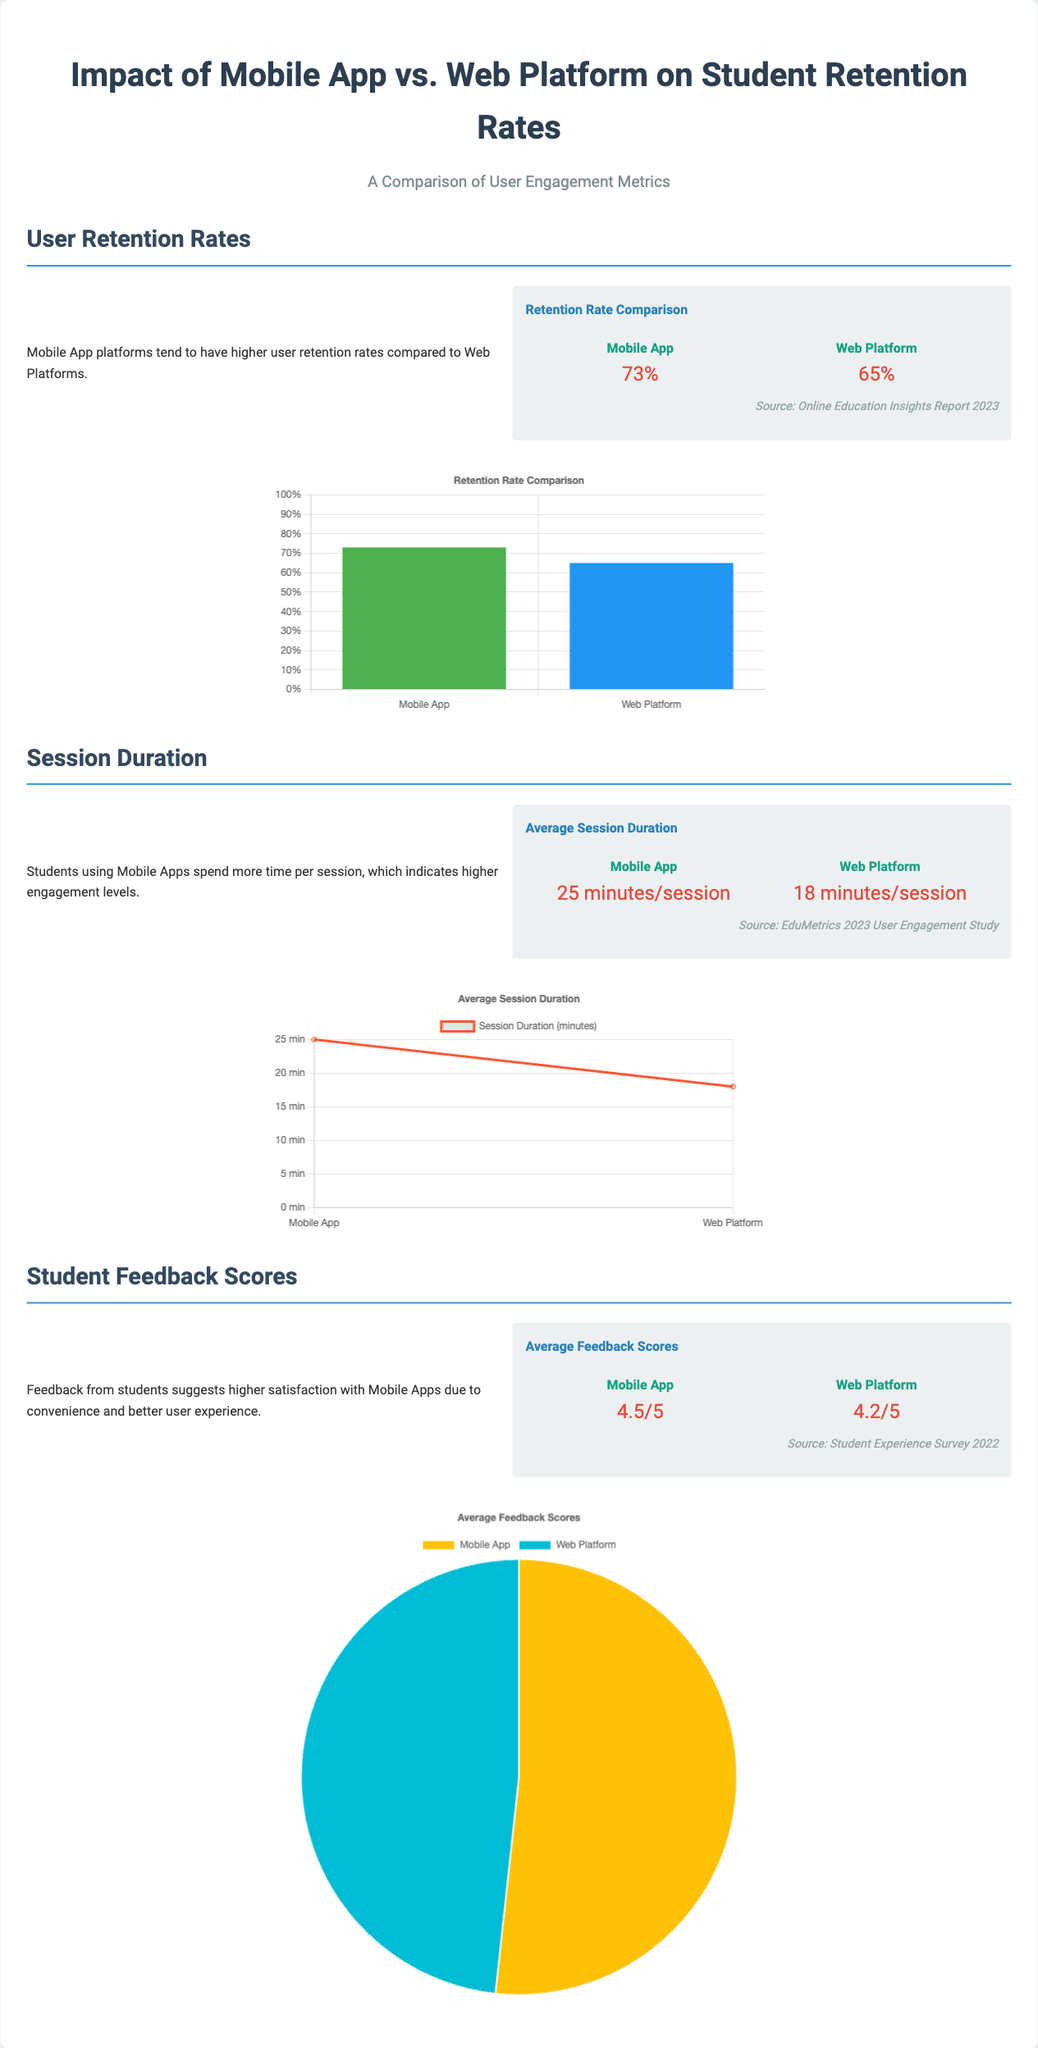what is the retention rate for Mobile App users? The document provides a specific statistic, stating that the retention rate for Mobile App users is 73%.
Answer: 73% what is the average session duration for Web Platform users? According to the document, the average session duration for Web Platform users is mentioned as 18 minutes/session.
Answer: 18 minutes/session which platform has a higher average feedback score? The document compares feedback scores and shows that the Mobile App has a higher average score of 4.5/5 compared to the Web Platform.
Answer: Mobile App what is the average feedback score for Mobile App users? The document states that the average feedback score for Mobile App users is 4.5 out of 5.
Answer: 4.5/5 which user engagement metric indicates higher user satisfaction? The document highlights that feedback scores suggest higher satisfaction with Mobile Apps, indicating that this metric is crucial for understanding user experience.
Answer: Feedback scores what is the difference in average session duration between Mobile App and Web Platform? The document shows the average session duration for Mobile App as 25 minutes/session and for Web Platform as 18 minutes/session, allowing us to calculate the difference.
Answer: 7 minutes which report source states the retention rates? The source indicating the retention rate comparison is the Online Education Insights Report 2023 according to the document.
Answer: Online Education Insights Report 2023 what type of chart is used to display average feedback scores? The document illustrates that a pie chart is used to represent the average feedback scores between the two platforms.
Answer: Pie chart what does the comparison of retention rates suggest about user engagement? The document suggests that higher retention rates for Mobile App platforms indicate stronger user engagement compared to Web Platforms.
Answer: Higher engagement 